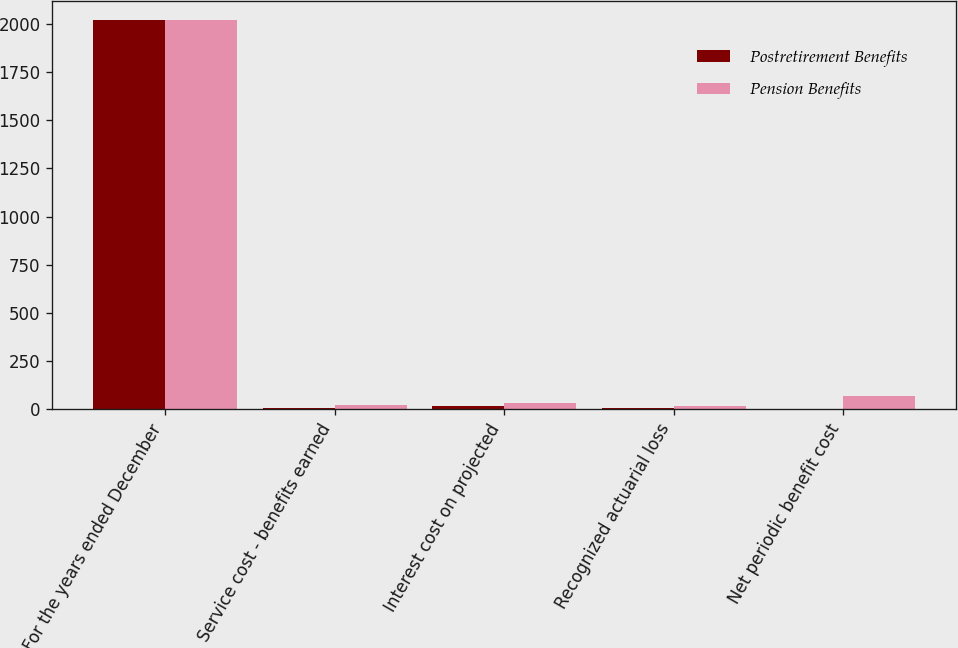Convert chart. <chart><loc_0><loc_0><loc_500><loc_500><stacked_bar_chart><ecel><fcel>For the years ended December<fcel>Service cost - benefits earned<fcel>Interest cost on projected<fcel>Recognized actuarial loss<fcel>Net periodic benefit cost<nl><fcel>Postretirement Benefits<fcel>2018<fcel>5<fcel>15<fcel>7<fcel>3<nl><fcel>Pension Benefits<fcel>2018<fcel>23<fcel>34<fcel>14<fcel>69<nl></chart> 